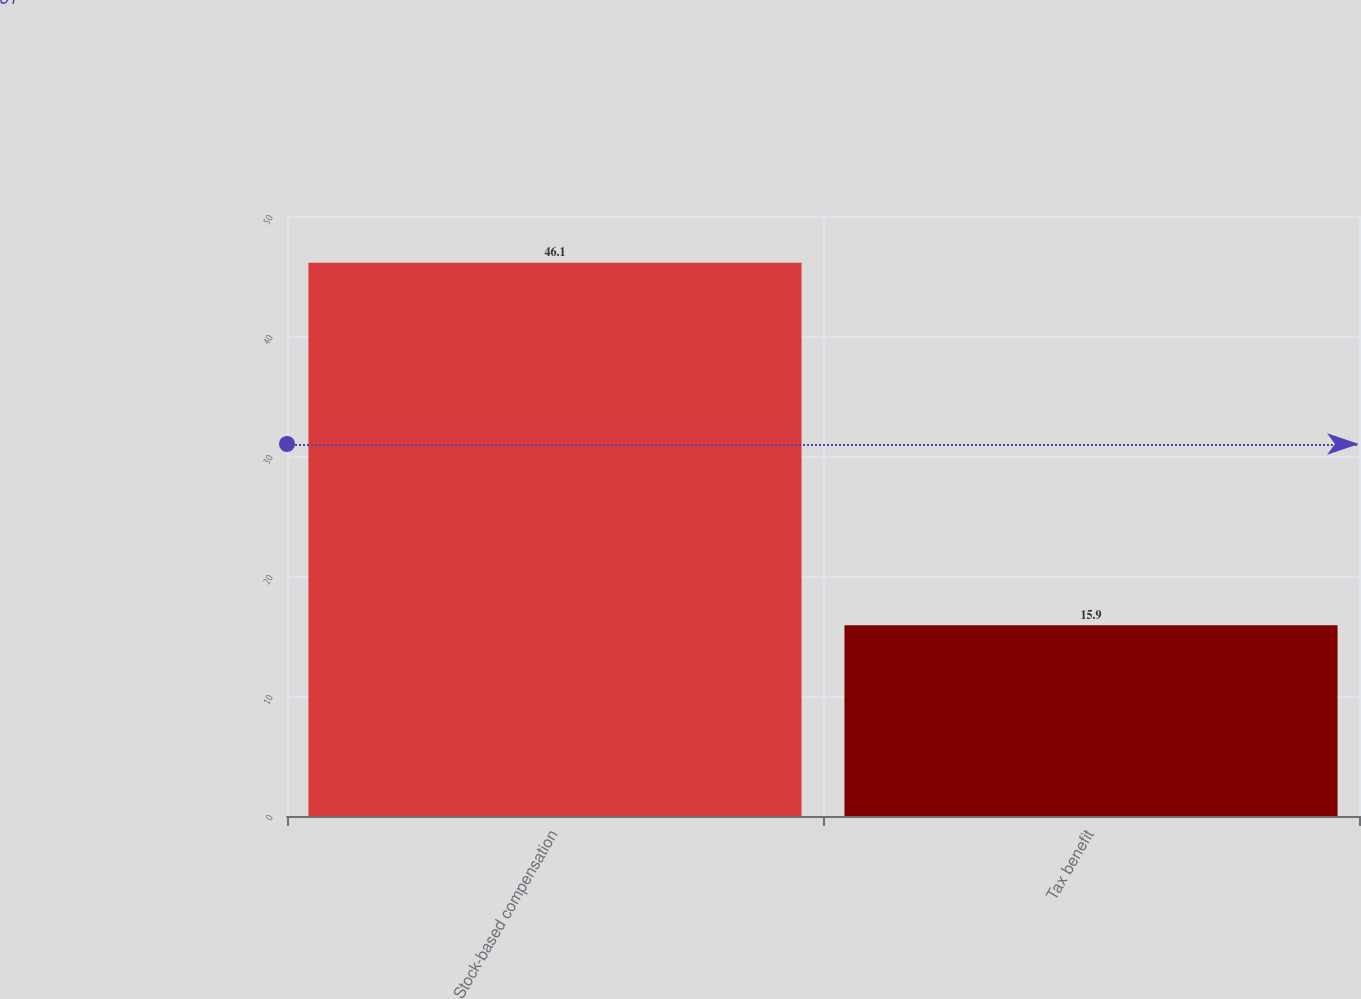Convert chart. <chart><loc_0><loc_0><loc_500><loc_500><bar_chart><fcel>Stock-based compensation<fcel>Tax benefit<nl><fcel>46.1<fcel>15.9<nl></chart> 